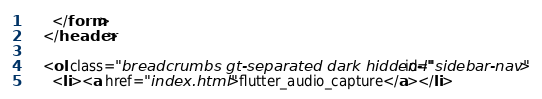Convert code to text. <code><loc_0><loc_0><loc_500><loc_500><_HTML_>      </form>
    </header>
    
    <ol class="breadcrumbs gt-separated dark hidden-l" id="sidebar-nav">
      <li><a href="index.html">flutter_audio_capture</a></li></code> 